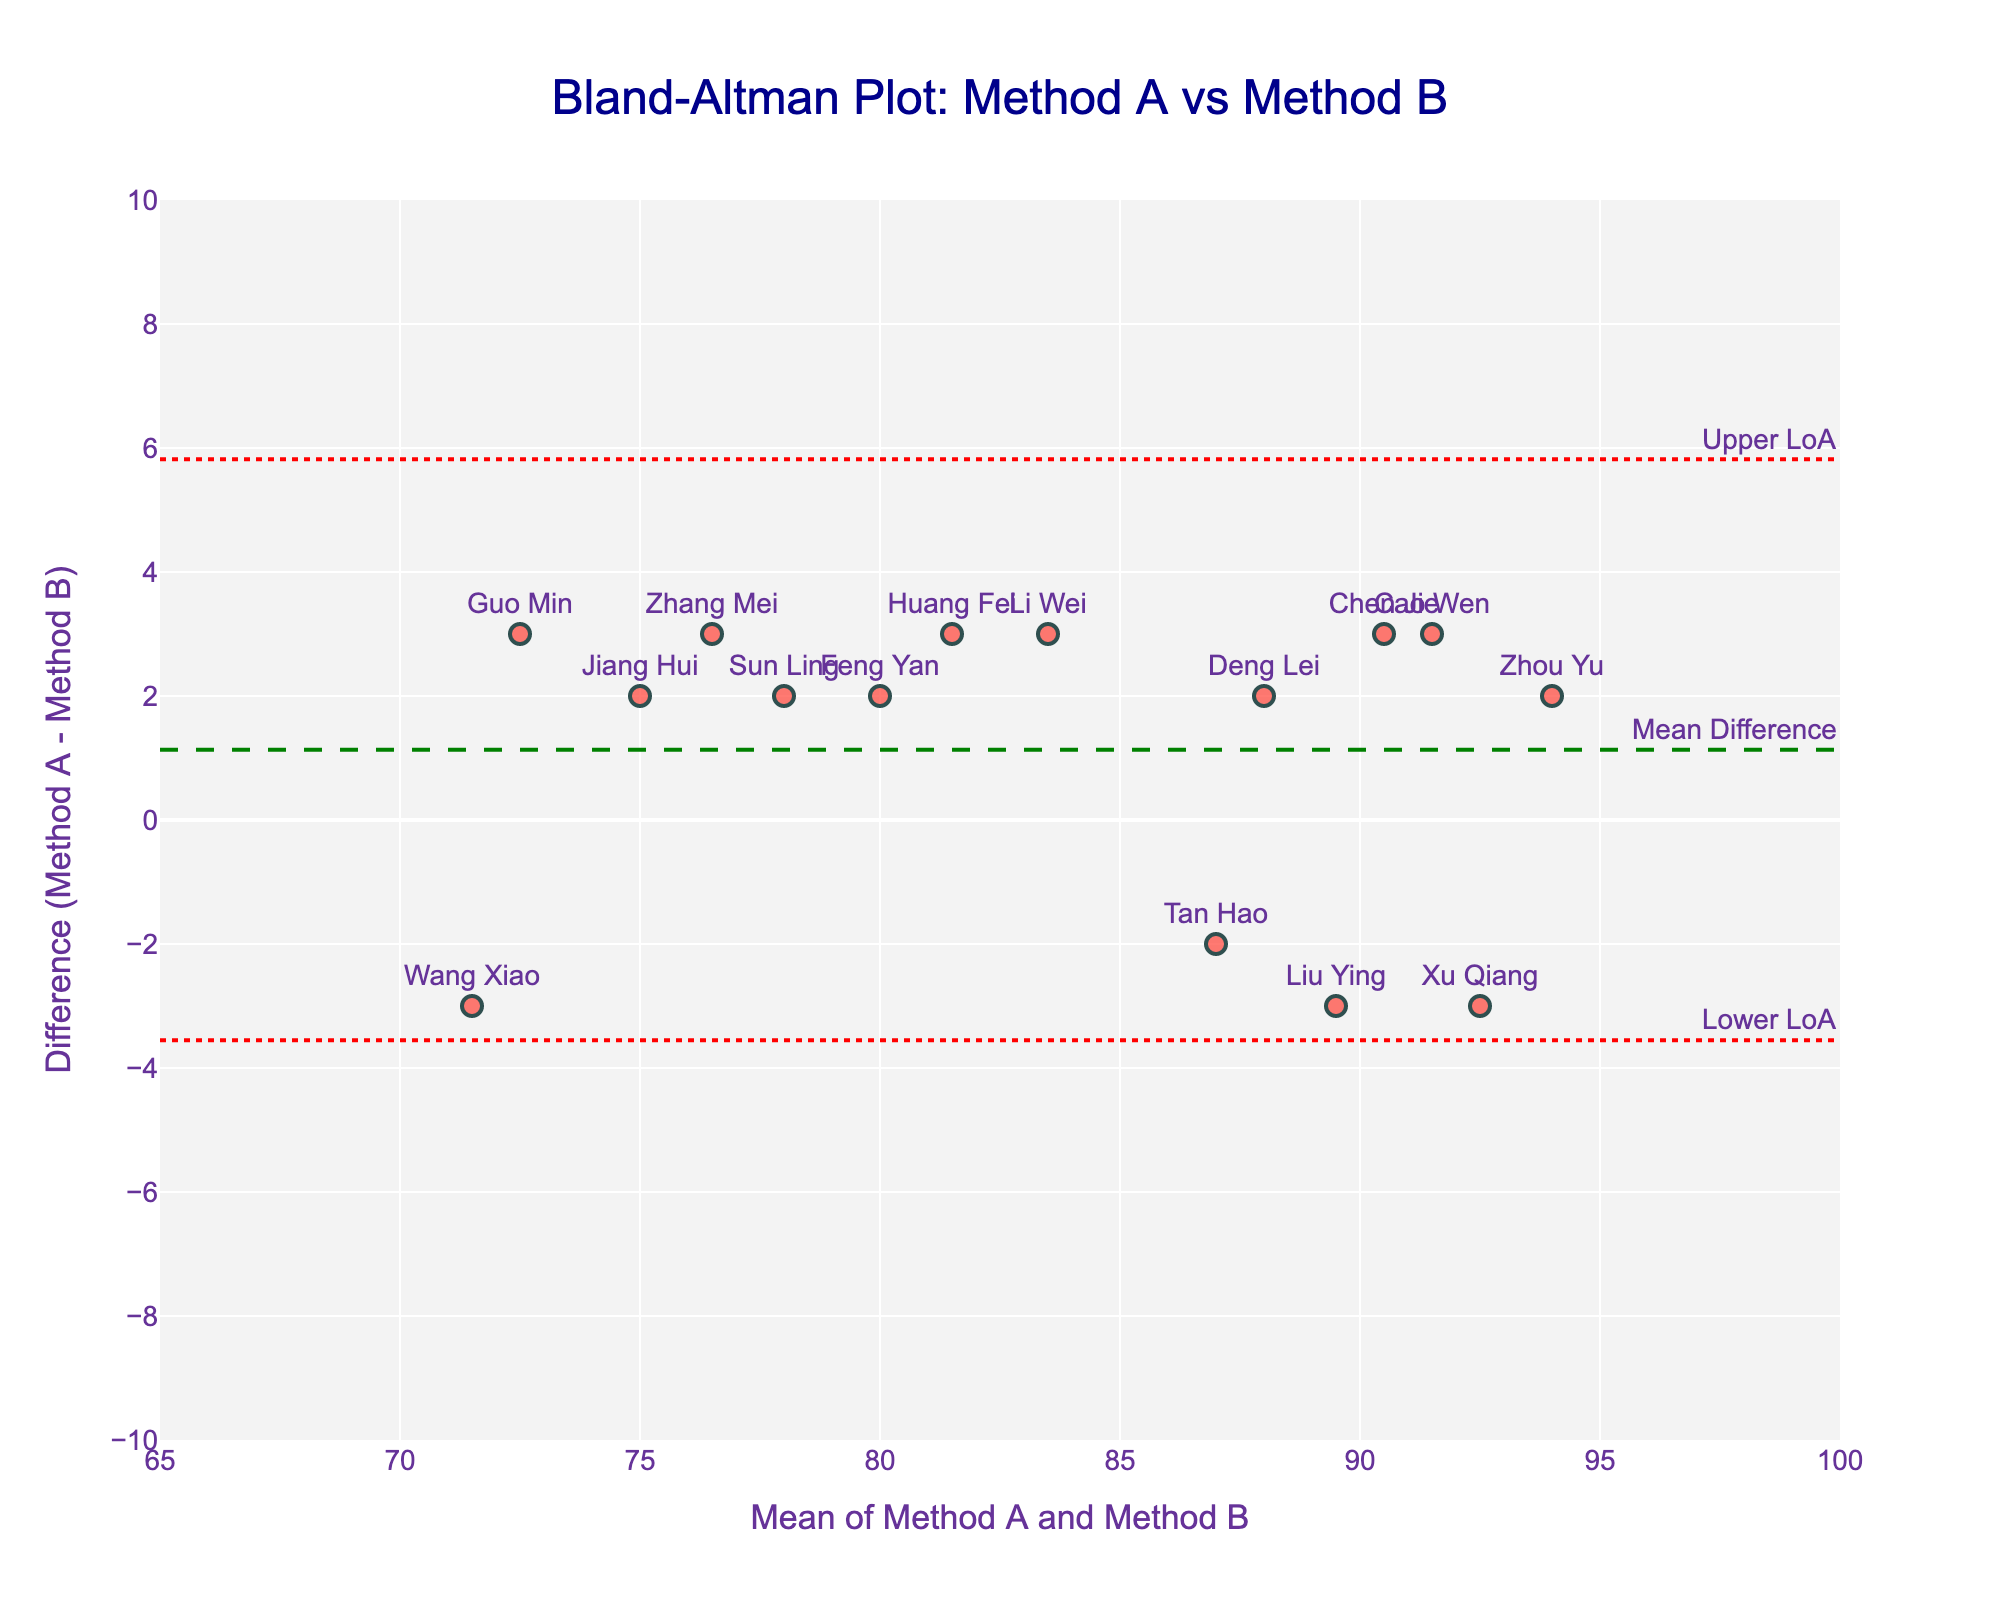What is the title of the figure? The title is usually found at the top of the figure and provides a brief description of what the figure represents.
Answer: Bland-Altman Plot: Method A vs Method B What information is shown on the x-axis? The x-axis is the horizontal axis of the graph. The label there provides a description of the data it represents.
Answer: Mean of Method A and Method B What are the labels on the y-axis? The y-axis is the vertical axis of the graph, and its label describes the type of data plotted in that direction.
Answer: Difference (Method A - Method B) How many data points are plotted in the figure? Each student has one data point on the plot. Count the total number of points or the number of students listed in the data.
Answer: 15 What is the color of the data points? The color of the data points can be identified by visually inspecting the points plotted on the graph.
Answer: Red What is the range of the x-axis? The range of the x-axis can be found by looking at its minimum and maximum values on the graph.
Answer: 65 to 100 By how much does Method A's mean score differ from Method B's mean score? Calculate the mean score for Method A and Method B, respectively, and then find the difference between these means.
Answer: 3 What is the value of the mean difference line? The mean difference line is represented by a horizontal line, and its value can be identified from the annotation on the graph.
Answer: 1.47 (approximately) Which student has the largest positive difference between Method A and Method B? Inspect the data points to find which one is highest above the mean difference line. The student's name should be labeled near the point.
Answer: Wang Xiao What are the upper and lower limits of agreement? The upper and lower limits of agreement are represented by dotted lines with annotations. Their values can be read directly from the graph.
Answer: Upper LoA: 4.83, Lower LoA: -1.89 How many students have a negative difference between Method A and Method B? Count the number of data points that lie below the y=0 line. Data points below this line indicate a negative difference.
Answer: 12 Which student's scores have the smallest difference between Method A and Method B? Find the data point closest to the y=0 line, which indicates the smallest difference. The student's name should be labeled near the point.
Answer: Xu Qiang 